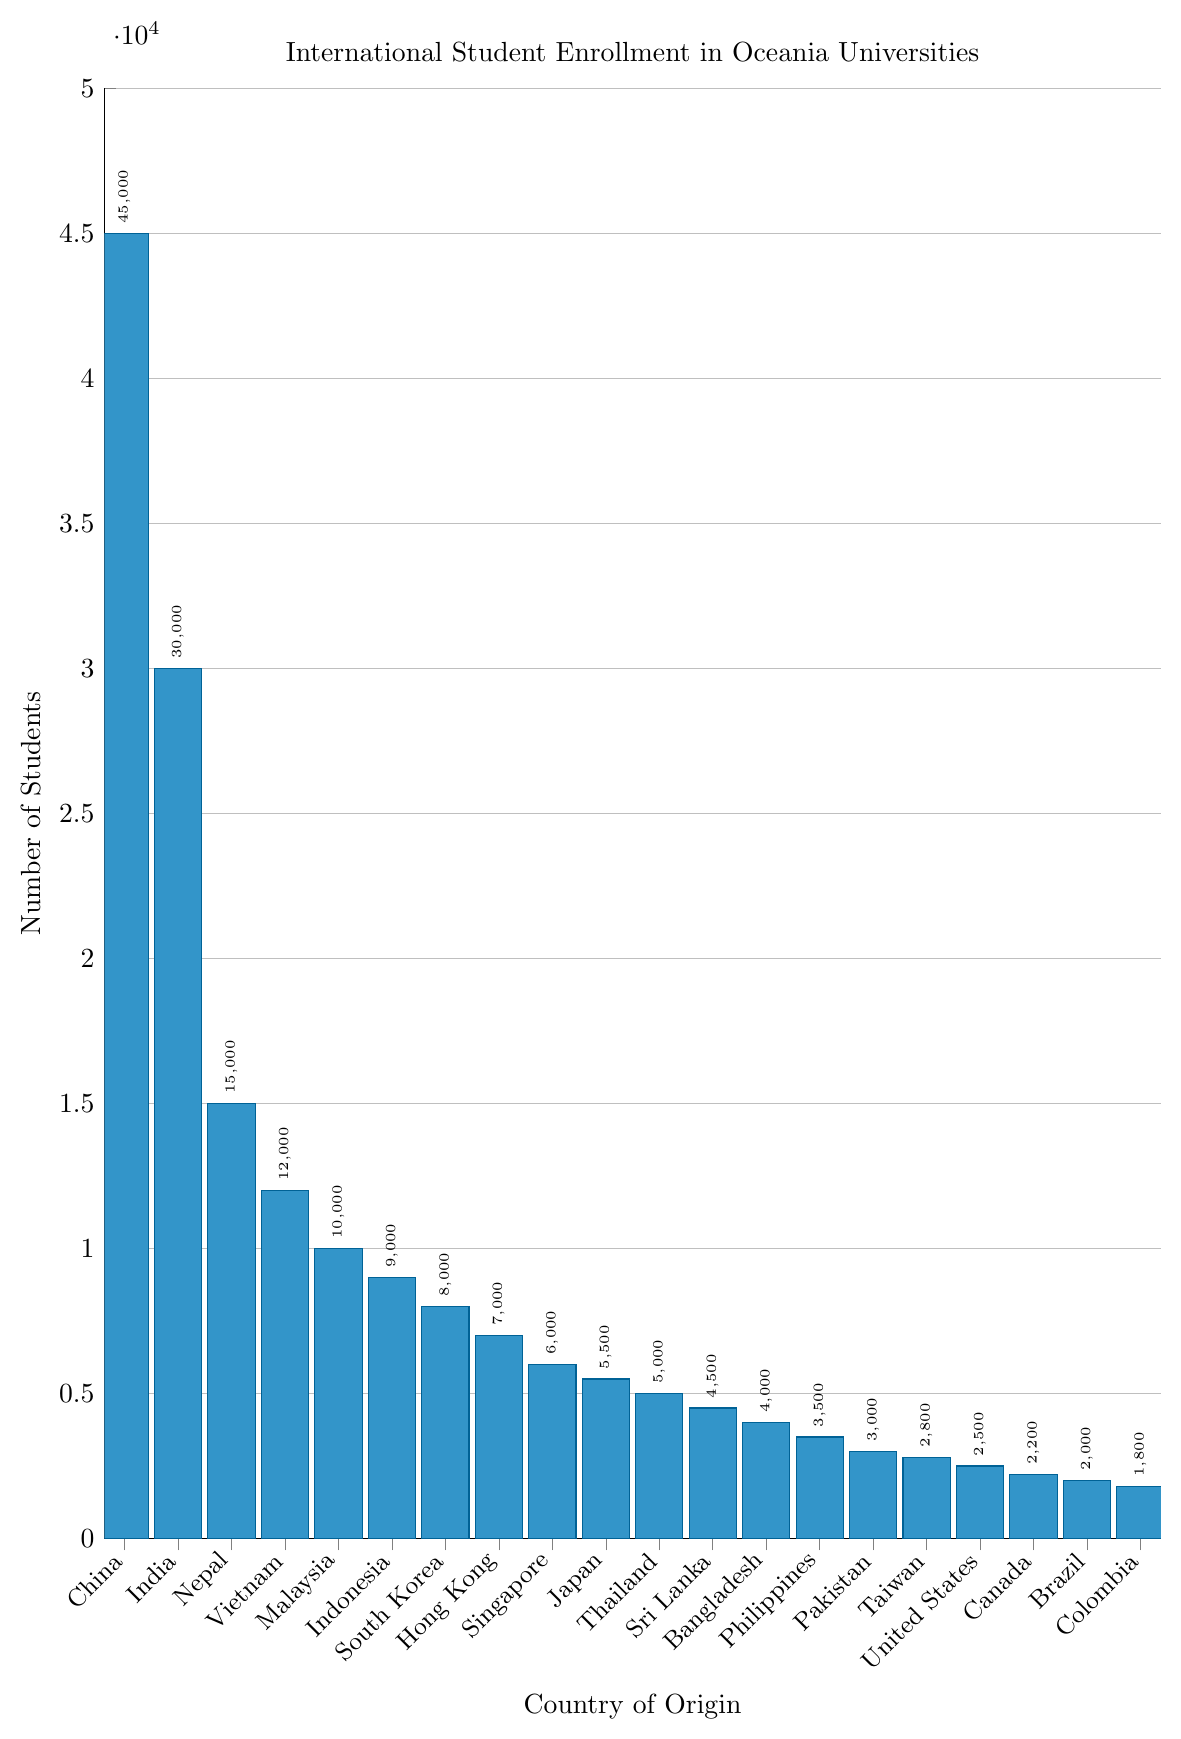How many more students come from China compared to India? According to the bar chart, China has 45,000 students while India has 30,000. Subtracting India's number from China's results in: 45,000 - 30,000 = 15,000
Answer: 15,000 Which country has the smallest number of students and how many students come from there? From the bar chart, the country with the smallest bar is Colombia, which indicates it has the fewest students. The number of students from Colombia is 1,800
Answer: Colombia, 1,800 What is the total number of students from Nepal, Vietnam, and Malaysia combined? Based on the chart, Nepal has 15,000 students, Vietnam has 12,000, and Malaysia has 10,000. Adding these numbers together: 15,000 + 12,000 + 10,000 = 37,000
Answer: 37,000 Which two countries have exactly the same number of students? By observing the lengths of the bars, no two bars are of equal height, thus no two countries have exactly the same number of students portrayed in the chart
Answer: None Compared to Japan, how many more students come from Indonesia? Indonesia has 9,000 students while Japan has 5,500. Subtracting Japan's number from Indonesia's: 9,000 - 5,500 = 3,500
Answer: 3,500 What is the average number of students from South Korea, Hong Kong, and Singapore? South Korea has 8,000 students, Hong Kong has 7,000, and Singapore has 6,000. Adding these numbers together: 8,000 + 7,000 + 6,000 = 21,000. To find the average: 21,000 / 3 = 7,000
Answer: 7,000 Which three countries have the highest number of students and what are their numbers? The three countries with the highest bars in the chart are China (45,000), India (30,000), and Nepal (15,000)
Answer: China, 45,000; India, 30,000; Nepal, 15,000 How many more students come from Pakistan compared to Taiwan and Canada combined? Pakistan has 3,000 students. Taiwan has 2,800 students and Canada has 2,200 students. Adding Taiwan and Canada's students: 2,800 + 2,200 = 5,000. The difference compared to Pakistan: 5,000 - 3,000 = 2,000
Answer: 2,000 What is the combined number of students from the top five countries? The top five countries are China (45,000), India (30,000), Nepal (15,000), Vietnam (12,000), and Malaysia (10,000). Adding these together: 45,000 + 30,000 + 15,000 + 12,000 + 10,000 = 112,000
Answer: 112,000 